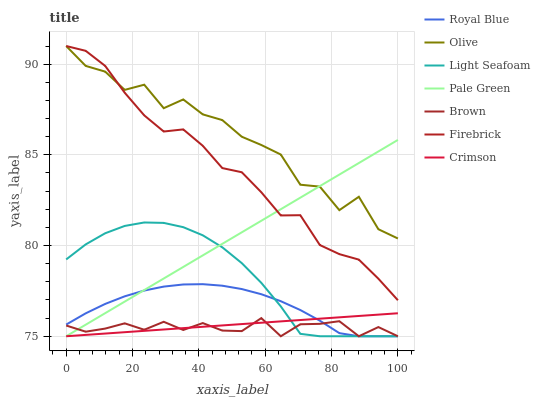Does Brown have the minimum area under the curve?
Answer yes or no. Yes. Does Olive have the maximum area under the curve?
Answer yes or no. Yes. Does Firebrick have the minimum area under the curve?
Answer yes or no. No. Does Firebrick have the maximum area under the curve?
Answer yes or no. No. Is Crimson the smoothest?
Answer yes or no. Yes. Is Olive the roughest?
Answer yes or no. Yes. Is Firebrick the smoothest?
Answer yes or no. No. Is Firebrick the roughest?
Answer yes or no. No. Does Firebrick have the lowest value?
Answer yes or no. No. Does Royal Blue have the highest value?
Answer yes or no. No. Is Brown less than Firebrick?
Answer yes or no. Yes. Is Firebrick greater than Brown?
Answer yes or no. Yes. Does Brown intersect Firebrick?
Answer yes or no. No. 